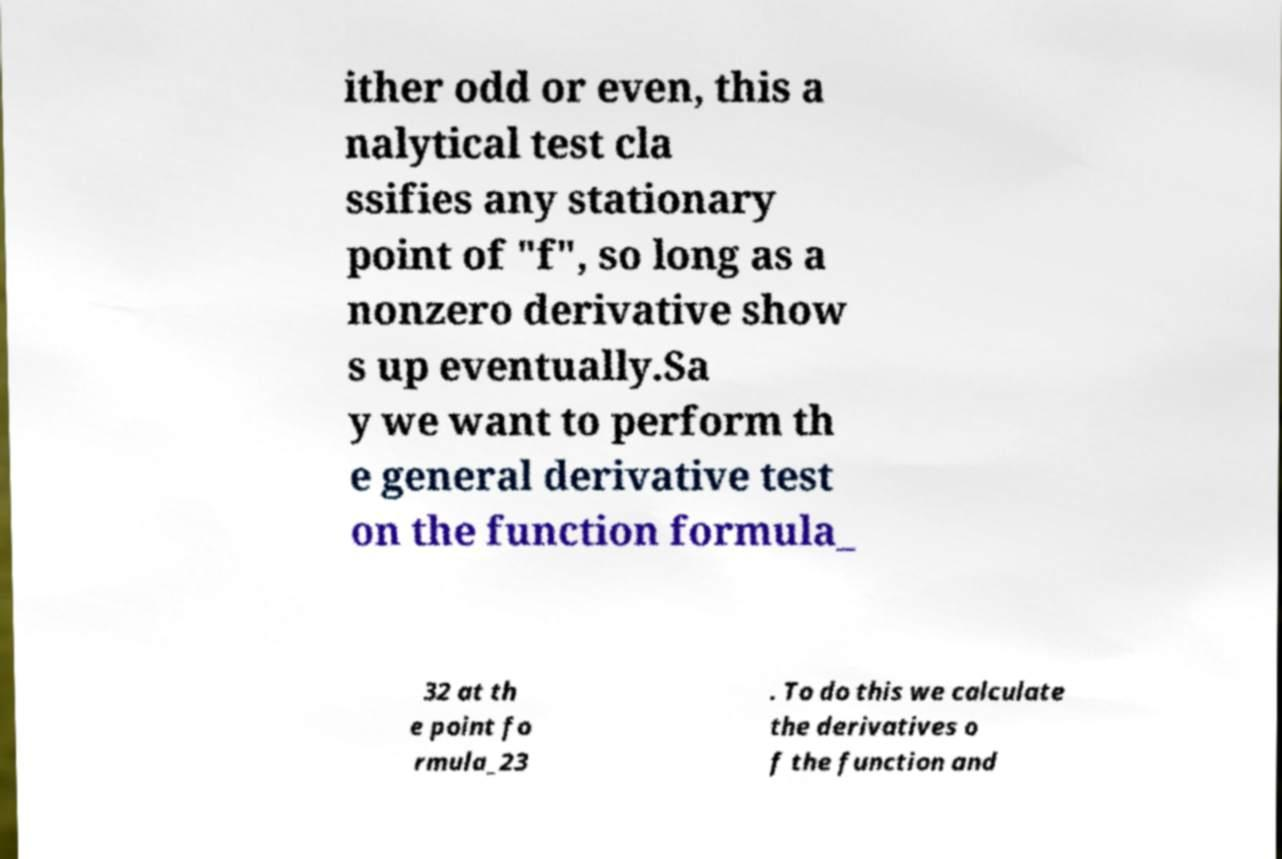Please identify and transcribe the text found in this image. ither odd or even, this a nalytical test cla ssifies any stationary point of "f", so long as a nonzero derivative show s up eventually.Sa y we want to perform th e general derivative test on the function formula_ 32 at th e point fo rmula_23 . To do this we calculate the derivatives o f the function and 